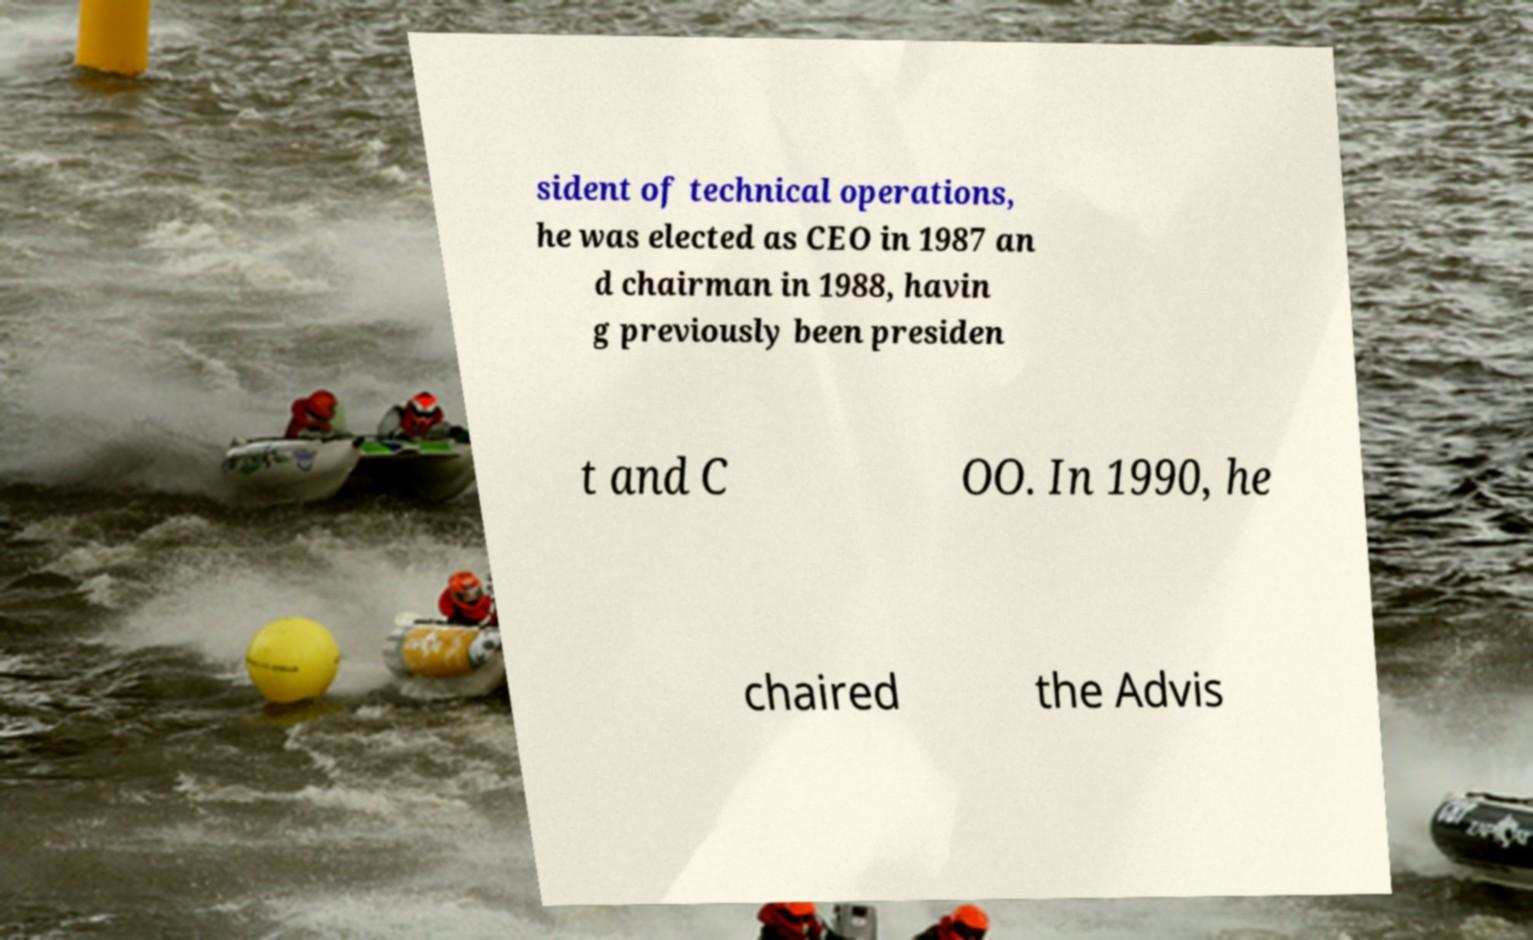Please identify and transcribe the text found in this image. sident of technical operations, he was elected as CEO in 1987 an d chairman in 1988, havin g previously been presiden t and C OO. In 1990, he chaired the Advis 